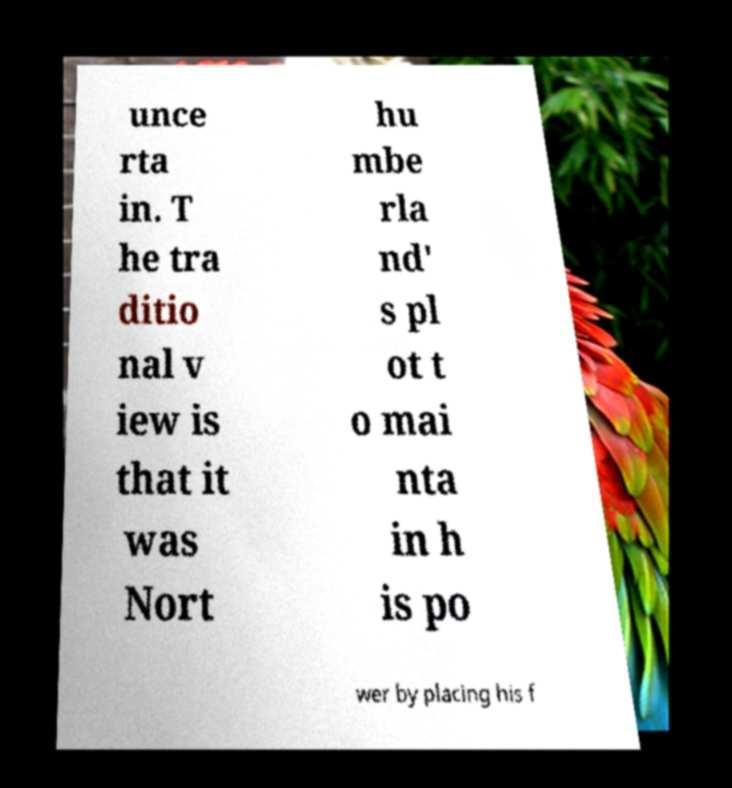For documentation purposes, I need the text within this image transcribed. Could you provide that? unce rta in. T he tra ditio nal v iew is that it was Nort hu mbe rla nd' s pl ot t o mai nta in h is po wer by placing his f 